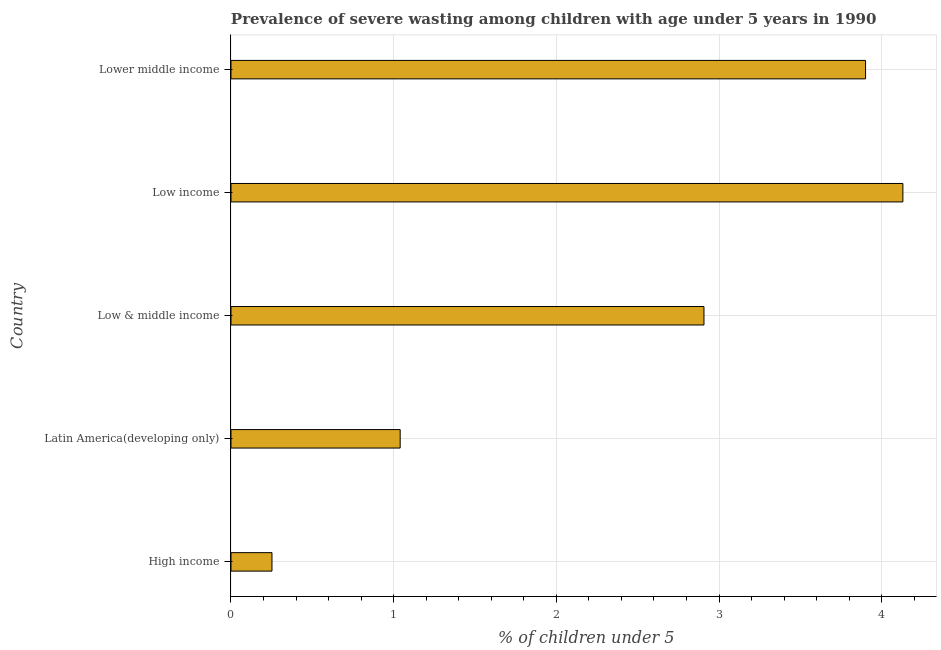Does the graph contain any zero values?
Provide a succinct answer. No. What is the title of the graph?
Provide a short and direct response. Prevalence of severe wasting among children with age under 5 years in 1990. What is the label or title of the X-axis?
Your response must be concise.  % of children under 5. What is the label or title of the Y-axis?
Offer a terse response. Country. What is the prevalence of severe wasting in Lower middle income?
Give a very brief answer. 3.9. Across all countries, what is the maximum prevalence of severe wasting?
Your answer should be very brief. 4.13. Across all countries, what is the minimum prevalence of severe wasting?
Make the answer very short. 0.25. In which country was the prevalence of severe wasting maximum?
Make the answer very short. Low income. In which country was the prevalence of severe wasting minimum?
Keep it short and to the point. High income. What is the sum of the prevalence of severe wasting?
Your answer should be very brief. 12.23. What is the difference between the prevalence of severe wasting in Latin America(developing only) and Low & middle income?
Provide a short and direct response. -1.87. What is the average prevalence of severe wasting per country?
Offer a terse response. 2.45. What is the median prevalence of severe wasting?
Your answer should be compact. 2.91. In how many countries, is the prevalence of severe wasting greater than 0.4 %?
Offer a terse response. 4. What is the ratio of the prevalence of severe wasting in Low & middle income to that in Lower middle income?
Keep it short and to the point. 0.74. Is the prevalence of severe wasting in High income less than that in Lower middle income?
Provide a succinct answer. Yes. What is the difference between the highest and the second highest prevalence of severe wasting?
Provide a short and direct response. 0.23. Is the sum of the prevalence of severe wasting in Latin America(developing only) and Low & middle income greater than the maximum prevalence of severe wasting across all countries?
Ensure brevity in your answer.  No. What is the difference between the highest and the lowest prevalence of severe wasting?
Offer a very short reply. 3.88. How many bars are there?
Ensure brevity in your answer.  5. How many countries are there in the graph?
Ensure brevity in your answer.  5. Are the values on the major ticks of X-axis written in scientific E-notation?
Give a very brief answer. No. What is the  % of children under 5 in High income?
Keep it short and to the point. 0.25. What is the  % of children under 5 of Latin America(developing only)?
Provide a succinct answer. 1.04. What is the  % of children under 5 in Low & middle income?
Keep it short and to the point. 2.91. What is the  % of children under 5 in Low income?
Keep it short and to the point. 4.13. What is the  % of children under 5 in Lower middle income?
Provide a succinct answer. 3.9. What is the difference between the  % of children under 5 in High income and Latin America(developing only)?
Offer a terse response. -0.79. What is the difference between the  % of children under 5 in High income and Low & middle income?
Keep it short and to the point. -2.66. What is the difference between the  % of children under 5 in High income and Low income?
Make the answer very short. -3.88. What is the difference between the  % of children under 5 in High income and Lower middle income?
Offer a very short reply. -3.65. What is the difference between the  % of children under 5 in Latin America(developing only) and Low & middle income?
Provide a succinct answer. -1.87. What is the difference between the  % of children under 5 in Latin America(developing only) and Low income?
Keep it short and to the point. -3.09. What is the difference between the  % of children under 5 in Latin America(developing only) and Lower middle income?
Keep it short and to the point. -2.86. What is the difference between the  % of children under 5 in Low & middle income and Low income?
Give a very brief answer. -1.22. What is the difference between the  % of children under 5 in Low & middle income and Lower middle income?
Provide a short and direct response. -0.99. What is the difference between the  % of children under 5 in Low income and Lower middle income?
Your answer should be compact. 0.23. What is the ratio of the  % of children under 5 in High income to that in Latin America(developing only)?
Your answer should be very brief. 0.24. What is the ratio of the  % of children under 5 in High income to that in Low & middle income?
Your answer should be compact. 0.09. What is the ratio of the  % of children under 5 in High income to that in Low income?
Give a very brief answer. 0.06. What is the ratio of the  % of children under 5 in High income to that in Lower middle income?
Ensure brevity in your answer.  0.07. What is the ratio of the  % of children under 5 in Latin America(developing only) to that in Low & middle income?
Offer a terse response. 0.36. What is the ratio of the  % of children under 5 in Latin America(developing only) to that in Low income?
Give a very brief answer. 0.25. What is the ratio of the  % of children under 5 in Latin America(developing only) to that in Lower middle income?
Provide a short and direct response. 0.27. What is the ratio of the  % of children under 5 in Low & middle income to that in Low income?
Ensure brevity in your answer.  0.7. What is the ratio of the  % of children under 5 in Low & middle income to that in Lower middle income?
Provide a succinct answer. 0.74. What is the ratio of the  % of children under 5 in Low income to that in Lower middle income?
Keep it short and to the point. 1.06. 